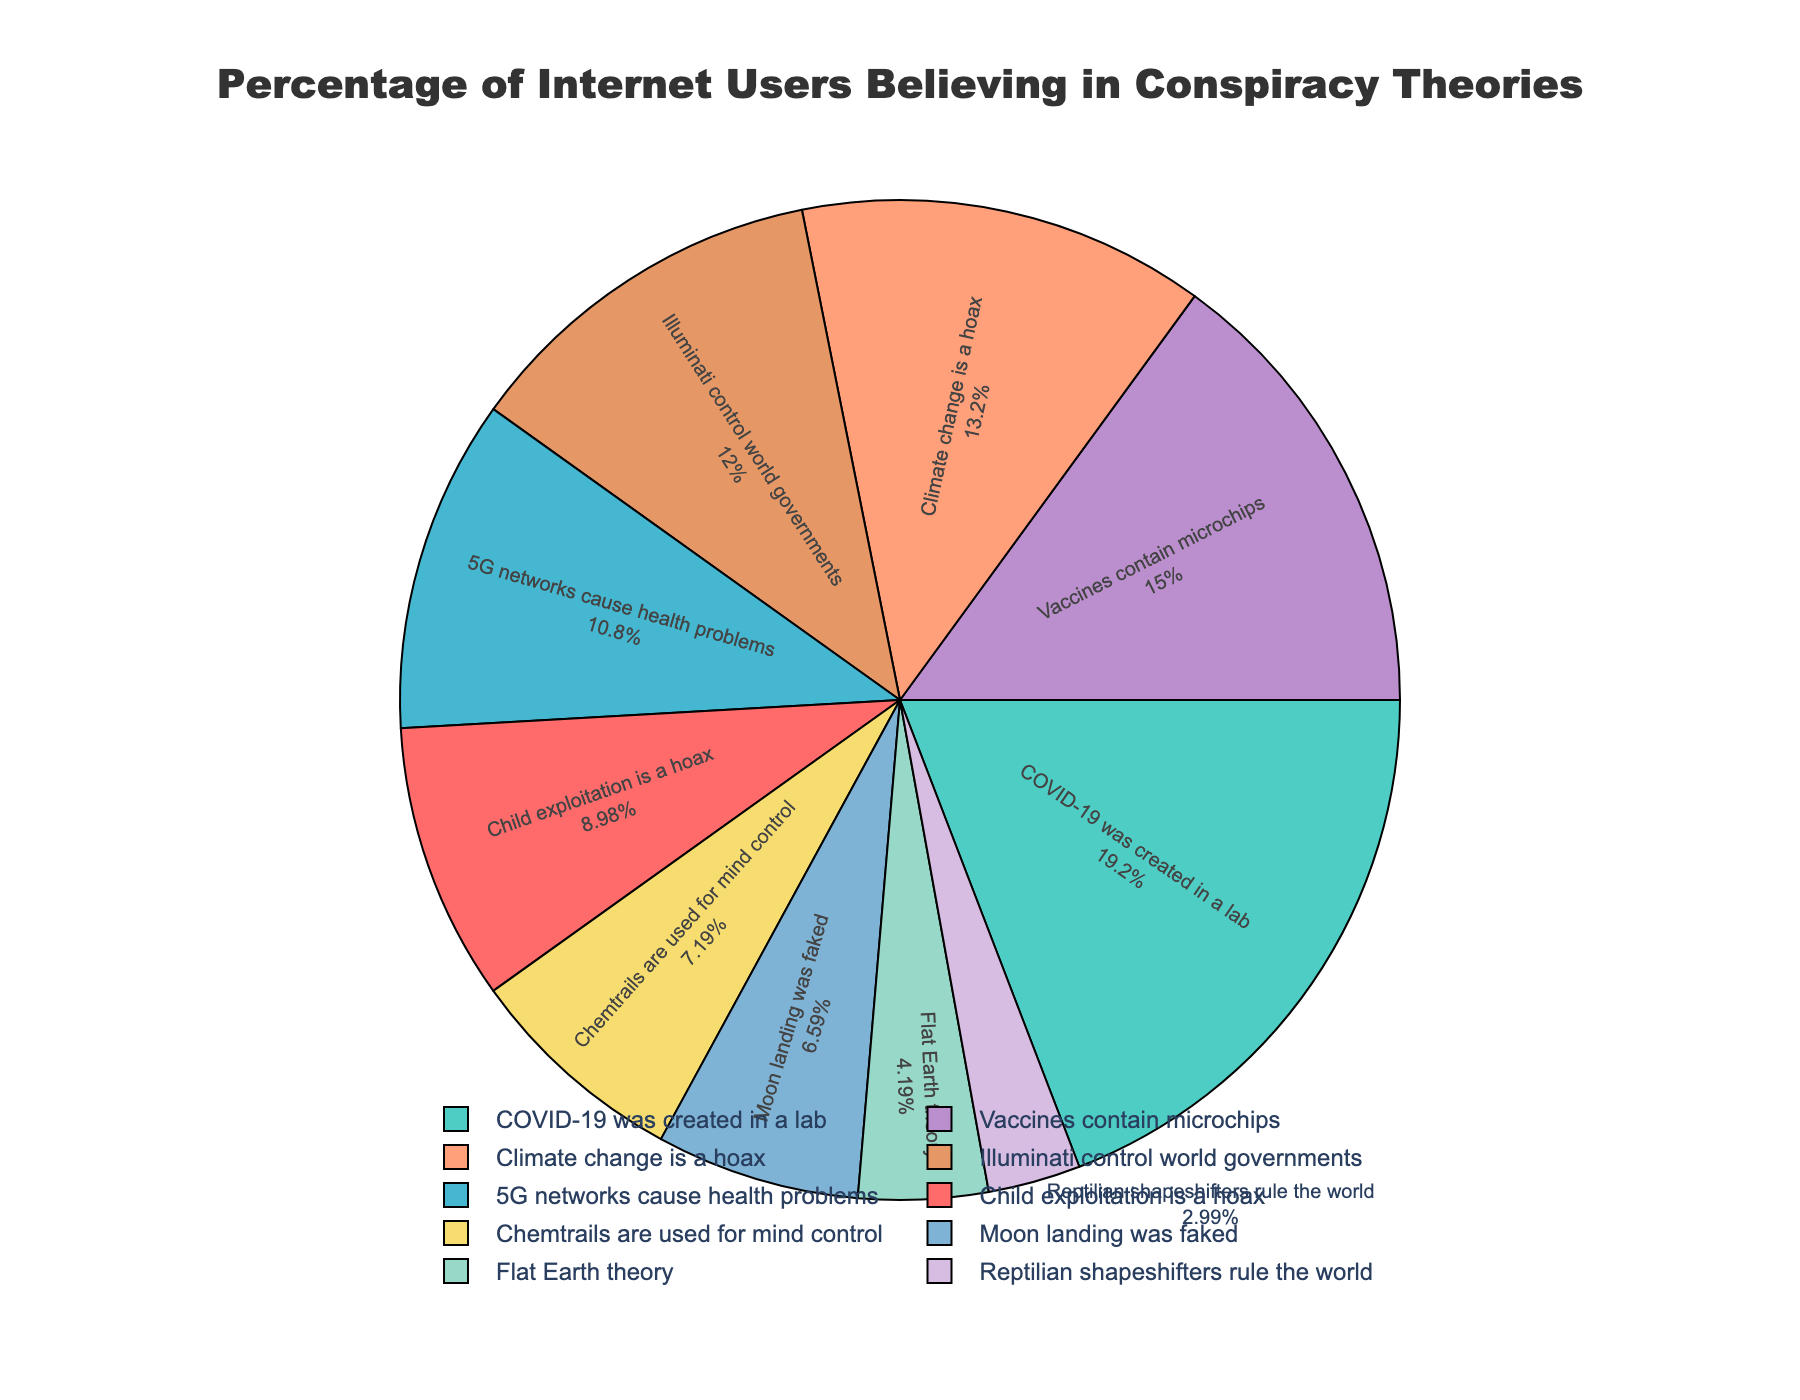Which conspiracy theory has the highest percentage of belief among internet users? The highest percentage value in the pie chart corresponds to the conspiracy theory that COVID-19 was created in a lab, with 32%.
Answer: COVID-19 was created in a lab Which conspiracy theory has the smallest proportion of believers? The smallest percentage value in the pie chart corresponds to the Reptilian shapeshifters rule the world conspiracy theory, with 5%.
Answer: Reptilian shapeshifters rule the world What is the total percentage of internet users who believe in both "Vaccines contain microchips" and "Illuminati control world governments"? Add the percentages for "Vaccines contain microchips" (25%) and "Illuminati control world governments" (20%). 25% + 20% = 45%.
Answer: 45% How does the percentage of believers in "Climate change is a hoax" compare to those who believe in "5G networks cause health problems"? The percentage of believers in "Climate change is a hoax" (22%) is 4 percentage points higher than those who believe in "5G networks cause health problems" (18%).
Answer: Climate change is a hoax has a higher percentage What is the average percentage of believers among the conspiracy theories listed? Add all the percentages and divide by the number of conspiracy theories. (15 + 32 + 18 + 22 + 7 + 12 + 25 + 11 + 20 + 5) / 10 = 167 / 10 = 16.7%.
Answer: 16.7% Which conspiracy theory depicted with green has what percentage of believers? The green color in the pie chart represents the conspiracy theory "5G networks cause health problems" with 18% believers.
Answer: 18% What is the total percentage of users who do not believe in "5G networks cause health problems" and "Moon landing was faked"? Subtract the percentage sum of "5G networks cause health problems" (18%) and "Moon landing was faked" (11%) from 100%. 100% - (18% + 11%) = 100% - 29% = 71%.
Answer: 71% What is the combined percentage for conspiracy theories believed by less than 10% of internet users? Add the percentages for "Flat Earth theory" (7%) and "Reptilian shapeshifters rule the world" (5%). 7% + 5% = 12%.
Answer: 12% Which conspiracy theories have a yellow or purple color in the pie chart, and what are their respective percentages? The yellow color represents "Chemtrails are used for mind control" with 12% believers, while the purple color represents "Illuminati control world governments" with 20% believers.
Answer: Chemtrails are used for mind control (12%), Illuminati control world governments (20%) 